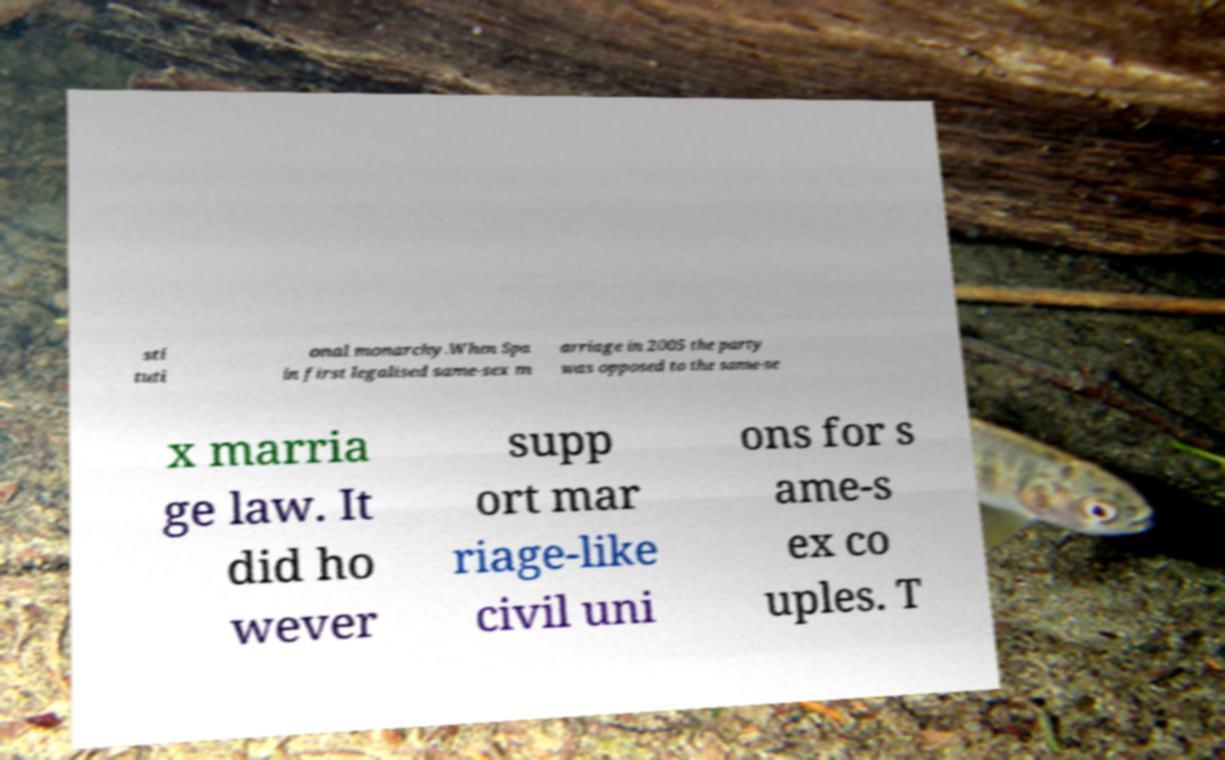Can you accurately transcribe the text from the provided image for me? sti tuti onal monarchy.When Spa in first legalised same-sex m arriage in 2005 the party was opposed to the same-se x marria ge law. It did ho wever supp ort mar riage-like civil uni ons for s ame-s ex co uples. T 